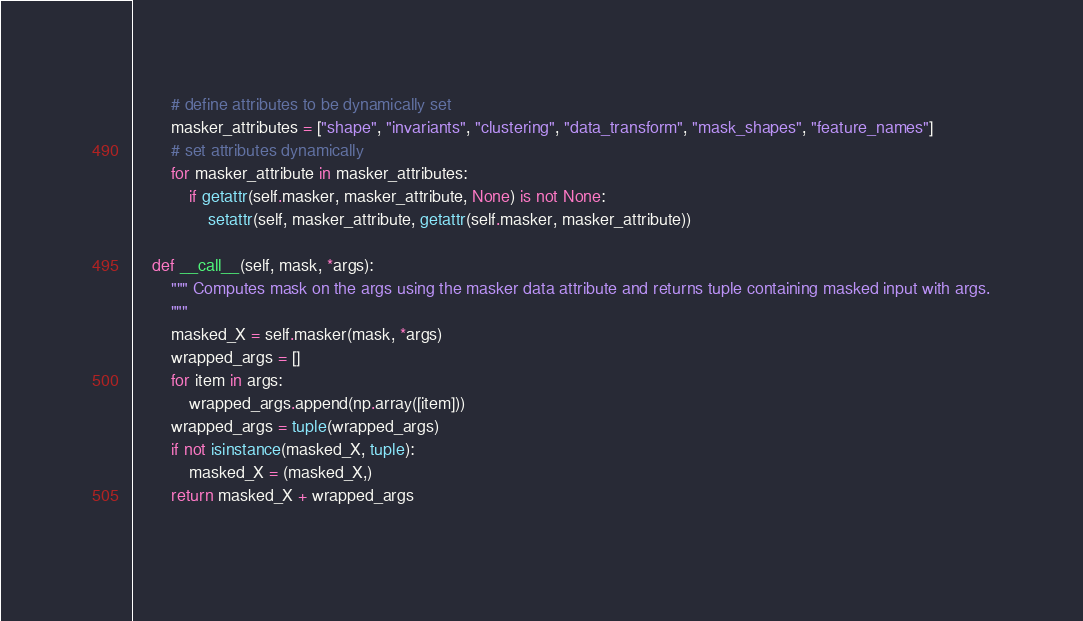<code> <loc_0><loc_0><loc_500><loc_500><_Python_>        # define attributes to be dynamically set
        masker_attributes = ["shape", "invariants", "clustering", "data_transform", "mask_shapes", "feature_names"]
        # set attributes dynamically
        for masker_attribute in masker_attributes:
            if getattr(self.masker, masker_attribute, None) is not None:
                setattr(self, masker_attribute, getattr(self.masker, masker_attribute))

    def __call__(self, mask, *args):
        """ Computes mask on the args using the masker data attribute and returns tuple containing masked input with args.
        """
        masked_X = self.masker(mask, *args)
        wrapped_args = []
        for item in args:
            wrapped_args.append(np.array([item]))
        wrapped_args = tuple(wrapped_args)
        if not isinstance(masked_X, tuple):
            masked_X = (masked_X,)
        return masked_X + wrapped_args
    </code> 